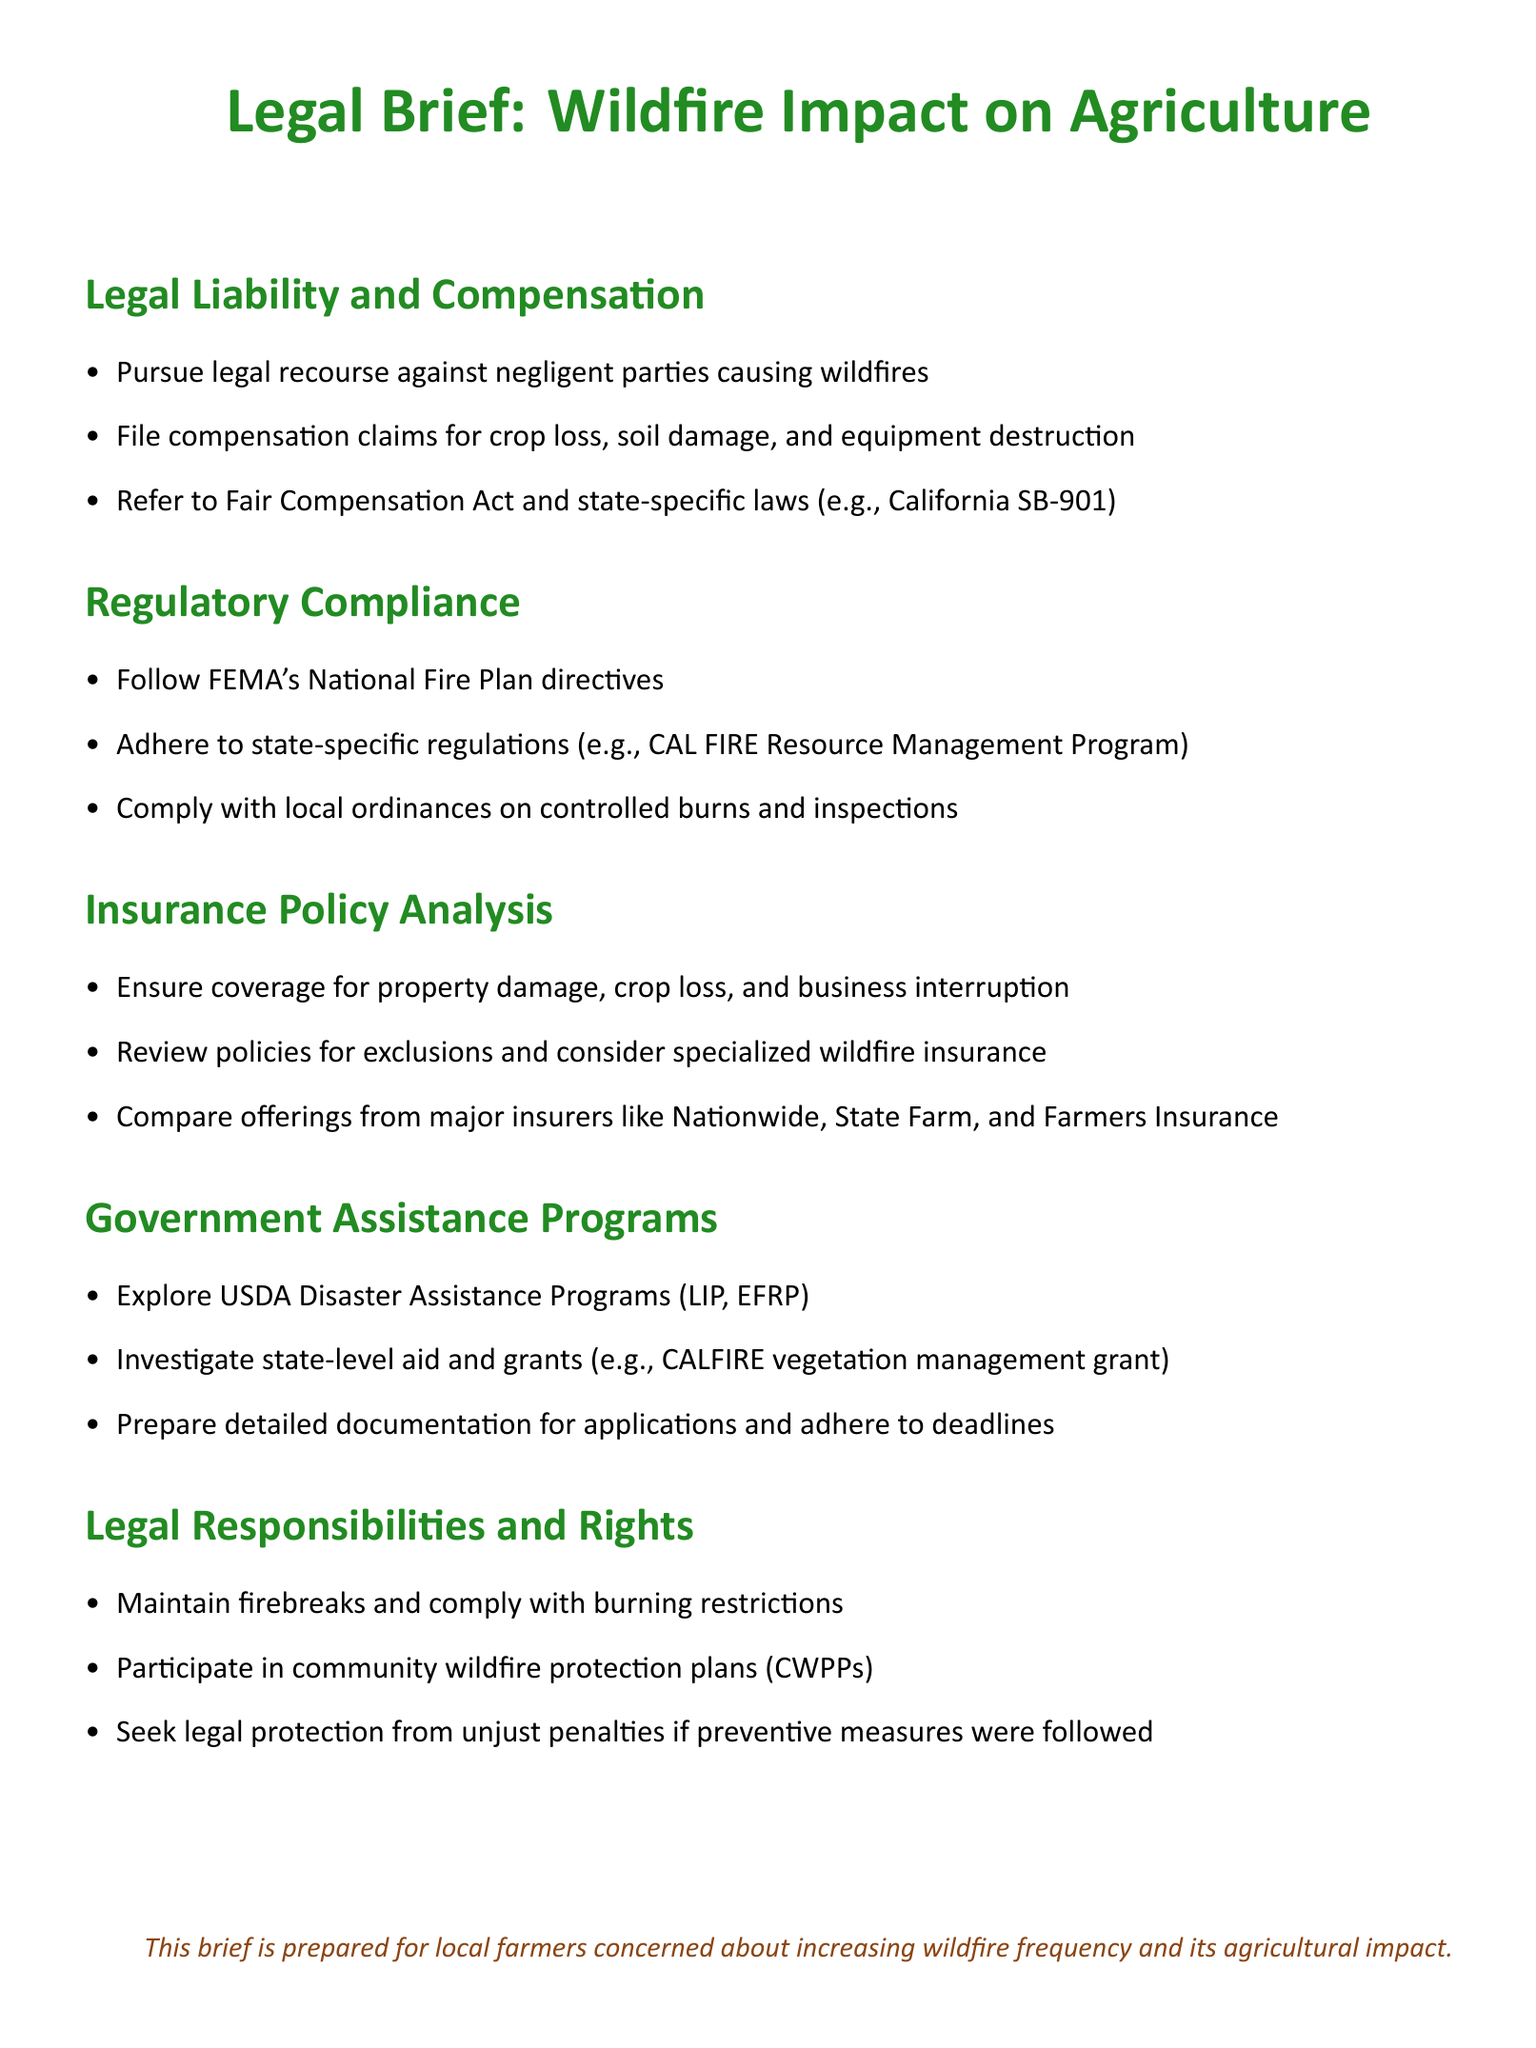What legal recourse can farmers pursue for damages? Farmers can pursue legal recourse against negligent parties causing wildfires.
Answer: Negligent parties What does the Fair Compensation Act relate to? The Fair Compensation Act refers to compensation claims for damages caused by wildfires.
Answer: Compensation claims What federal guidelines should farmers follow for wildfire prevention? Farmers should follow FEMA's National Fire Plan directives.
Answer: FEMA's National Fire Plan Which major insurers offer specialized wildfire insurance? Major insurers include Nationwide, State Farm, and Farmers Insurance.
Answer: Nationwide, State Farm, Farmers Insurance Which USDA program assists with livestock losses? The USDA program that assists with livestock losses is LIP.
Answer: LIP What are farmers' responsibilities regarding firebreaks? Farmers must maintain firebreaks and comply with burning restrictions.
Answer: Maintain firebreaks What state-level grant can farmers investigate for wildfire aid? Farmers can investigate the CALFIRE vegetation management grant.
Answer: CALFIRE vegetation management grant What is needed for government assistance program applications? Applications require detailed documentation and adherence to deadlines.
Answer: Detailed documentation What is the significance of participating in community wildfire protection plans? It relates to farmers’ rights under local initiatives concerning wildfire containment.
Answer: Community wildfire protection plans 